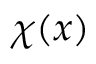<formula> <loc_0><loc_0><loc_500><loc_500>\chi ( x )</formula> 